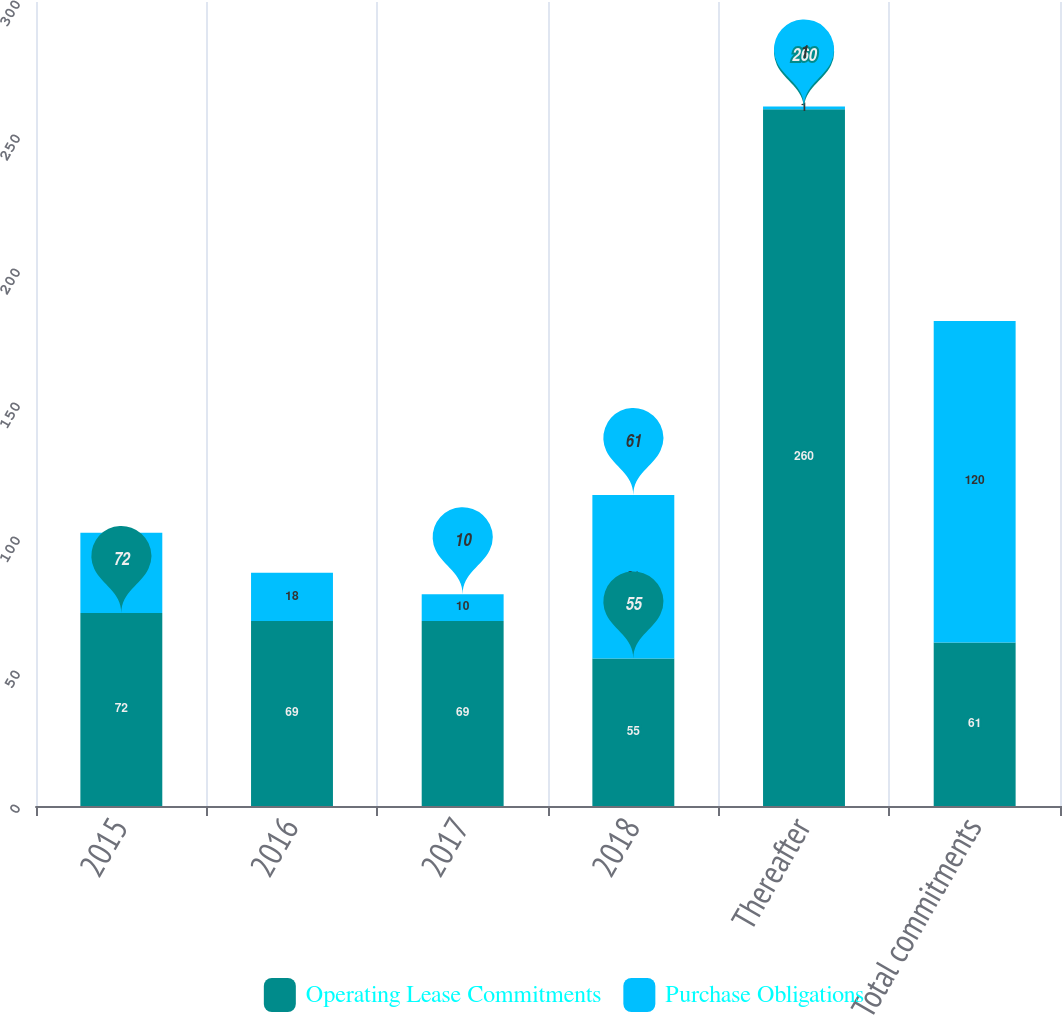<chart> <loc_0><loc_0><loc_500><loc_500><stacked_bar_chart><ecel><fcel>2015<fcel>2016<fcel>2017<fcel>2018<fcel>Thereafter<fcel>Total commitments<nl><fcel>Operating Lease Commitments<fcel>72<fcel>69<fcel>69<fcel>55<fcel>260<fcel>61<nl><fcel>Purchase Obligations<fcel>30<fcel>18<fcel>10<fcel>61<fcel>1<fcel>120<nl></chart> 